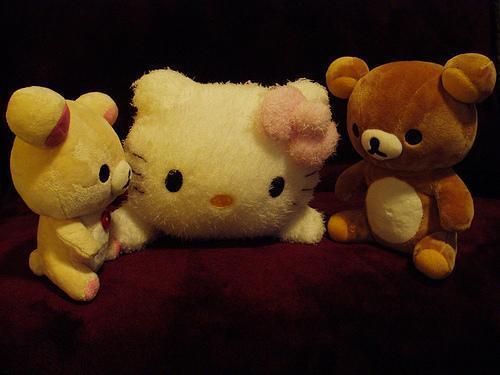How many animals are pictured here?
Give a very brief answer. 3. How many of these animals are real?
Give a very brief answer. 0. How many teddy bears are pictured?
Give a very brief answer. 2. How many brown teddy bears are pictured?
Give a very brief answer. 1. How many stuffed animals are there?
Give a very brief answer. 3. How many teddy bears are there?
Give a very brief answer. 2. 